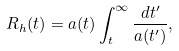<formula> <loc_0><loc_0><loc_500><loc_500>R _ { h } ( t ) = a ( t ) \int _ { t } ^ { \infty } \frac { d t ^ { \prime } } { a ( t ^ { \prime } ) } ,</formula> 